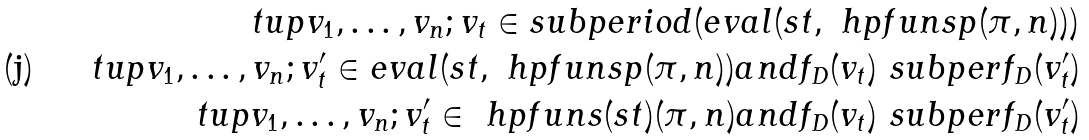<formula> <loc_0><loc_0><loc_500><loc_500>\ t u p { v _ { 1 } , \dots , v _ { n } ; v _ { t } } \in s u b p e r i o d ( e v a l ( s t , \ h p f u n s p ( \pi , n ) ) ) \\ \ t u p { v _ { 1 } , \dots , v _ { n } ; v _ { t } ^ { \prime } } \in e v a l ( s t , \ h p f u n s p ( \pi , n ) ) a n d f _ { D } ( v _ { t } ) \ s u b p e r f _ { D } ( v _ { t } ^ { \prime } ) \\ \ t u p { v _ { 1 } , \dots , v _ { n } ; v _ { t } ^ { \prime } } \in \ h p f u n s ( s t ) ( \pi , n ) a n d f _ { D } ( v _ { t } ) \ s u b p e r f _ { D } ( v _ { t } ^ { \prime } )</formula> 